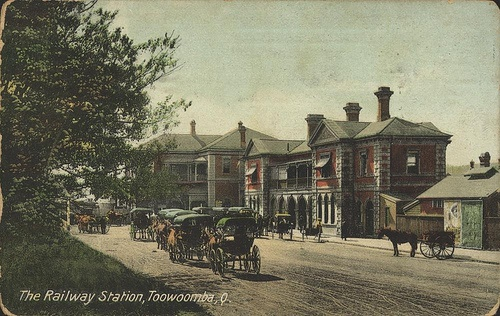Describe the objects in this image and their specific colors. I can see horse in black and gray tones, people in black, gray, and tan tones, and people in black, darkgray, and gray tones in this image. 